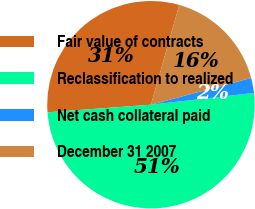<chart> <loc_0><loc_0><loc_500><loc_500><pie_chart><fcel>Fair value of contracts<fcel>Reclassification to realized<fcel>Net cash collateral paid<fcel>December 31 2007<nl><fcel>30.57%<fcel>50.64%<fcel>2.34%<fcel>16.45%<nl></chart> 